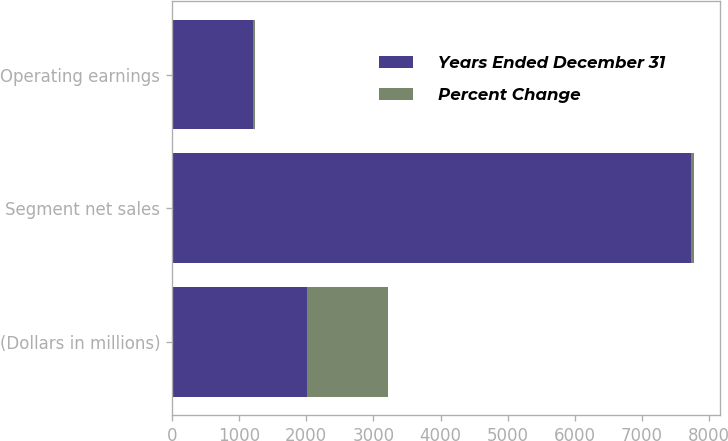Convert chart to OTSL. <chart><loc_0><loc_0><loc_500><loc_500><stacked_bar_chart><ecel><fcel>(Dollars in millions)<fcel>Segment net sales<fcel>Operating earnings<nl><fcel>Years Ended December 31<fcel>2007<fcel>7729<fcel>1213<nl><fcel>Percent Change<fcel>1213<fcel>43<fcel>27<nl></chart> 